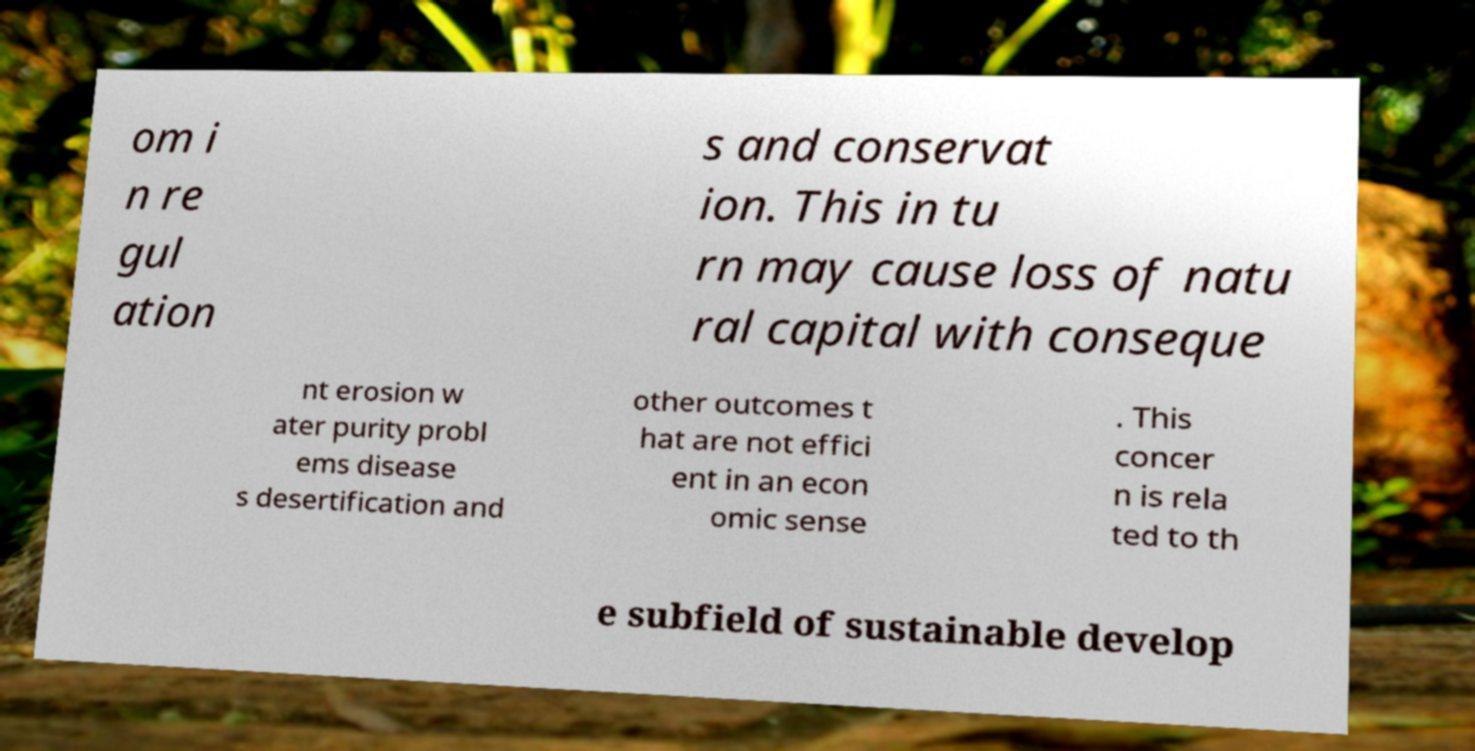Can you read and provide the text displayed in the image?This photo seems to have some interesting text. Can you extract and type it out for me? om i n re gul ation s and conservat ion. This in tu rn may cause loss of natu ral capital with conseque nt erosion w ater purity probl ems disease s desertification and other outcomes t hat are not effici ent in an econ omic sense . This concer n is rela ted to th e subfield of sustainable develop 